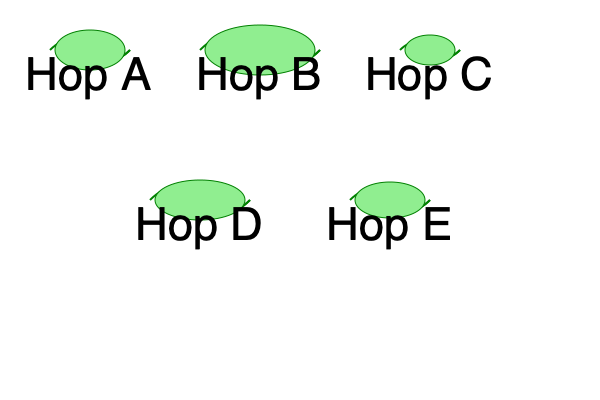Based on the illustrations provided, which hop variety is known for its large, elongated cones and is often used to impart a strong, bitter flavor to IPAs? To answer this question, let's analyze the characteristics of each hop variety shown in the illustration:

1. Hop A: Medium-sized, oval-shaped cone
2. Hop B: Large, elongated cone
3. Hop C: Small, compact cone
4. Hop D: Medium to large, slightly elongated cone
5. Hop E: Medium-sized, oval-shaped cone

Among these varieties, Hop B stands out with its distinctively large and elongated cone shape. In craft beer brewing, hop varieties with larger cones are often associated with higher alpha acid content, which contributes to the bitter flavor in beer.

IPAs (India Pale Ales) are known for their strong, bitter flavor profiles, which are achieved by using hop varieties with high alpha acid content. These hops are typically added during the boiling process to extract maximum bitterness.

Given the characteristics of Hop B and its similarity to hop varieties commonly used in IPAs, it is the most likely candidate for imparting a strong, bitter flavor to this beer style.
Answer: Hop B 